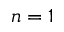Convert formula to latex. <formula><loc_0><loc_0><loc_500><loc_500>n = 1</formula> 